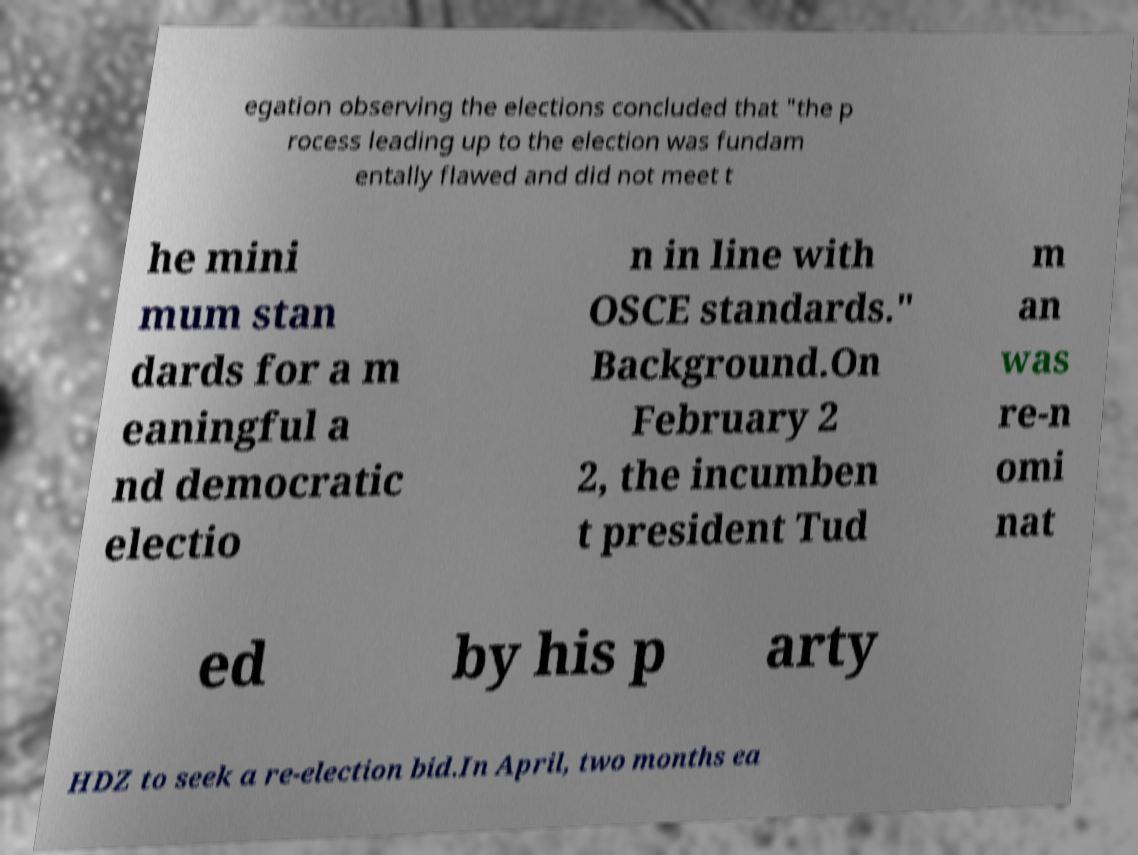I need the written content from this picture converted into text. Can you do that? egation observing the elections concluded that "the p rocess leading up to the election was fundam entally flawed and did not meet t he mini mum stan dards for a m eaningful a nd democratic electio n in line with OSCE standards." Background.On February 2 2, the incumben t president Tud m an was re-n omi nat ed by his p arty HDZ to seek a re-election bid.In April, two months ea 